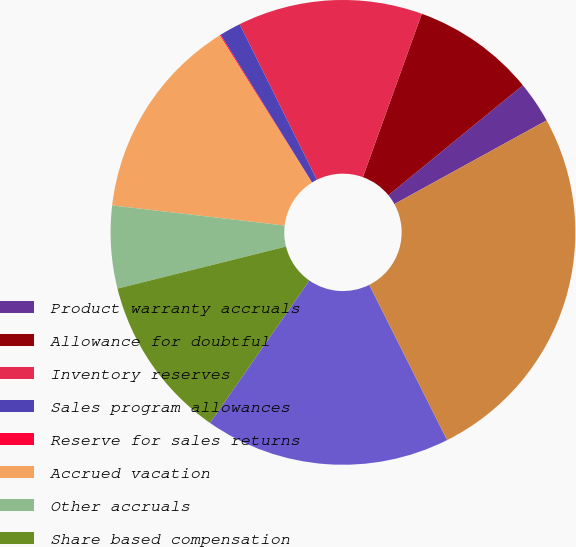Convert chart to OTSL. <chart><loc_0><loc_0><loc_500><loc_500><pie_chart><fcel>Product warranty accruals<fcel>Allowance for doubtful<fcel>Inventory reserves<fcel>Sales program allowances<fcel>Reserve for sales returns<fcel>Accrued vacation<fcel>Other accruals<fcel>Share based compensation<fcel>Tax credit carryforwards<fcel>Amortization<nl><fcel>2.91%<fcel>8.58%<fcel>12.84%<fcel>1.49%<fcel>0.07%<fcel>14.26%<fcel>5.74%<fcel>11.42%<fcel>17.09%<fcel>25.6%<nl></chart> 